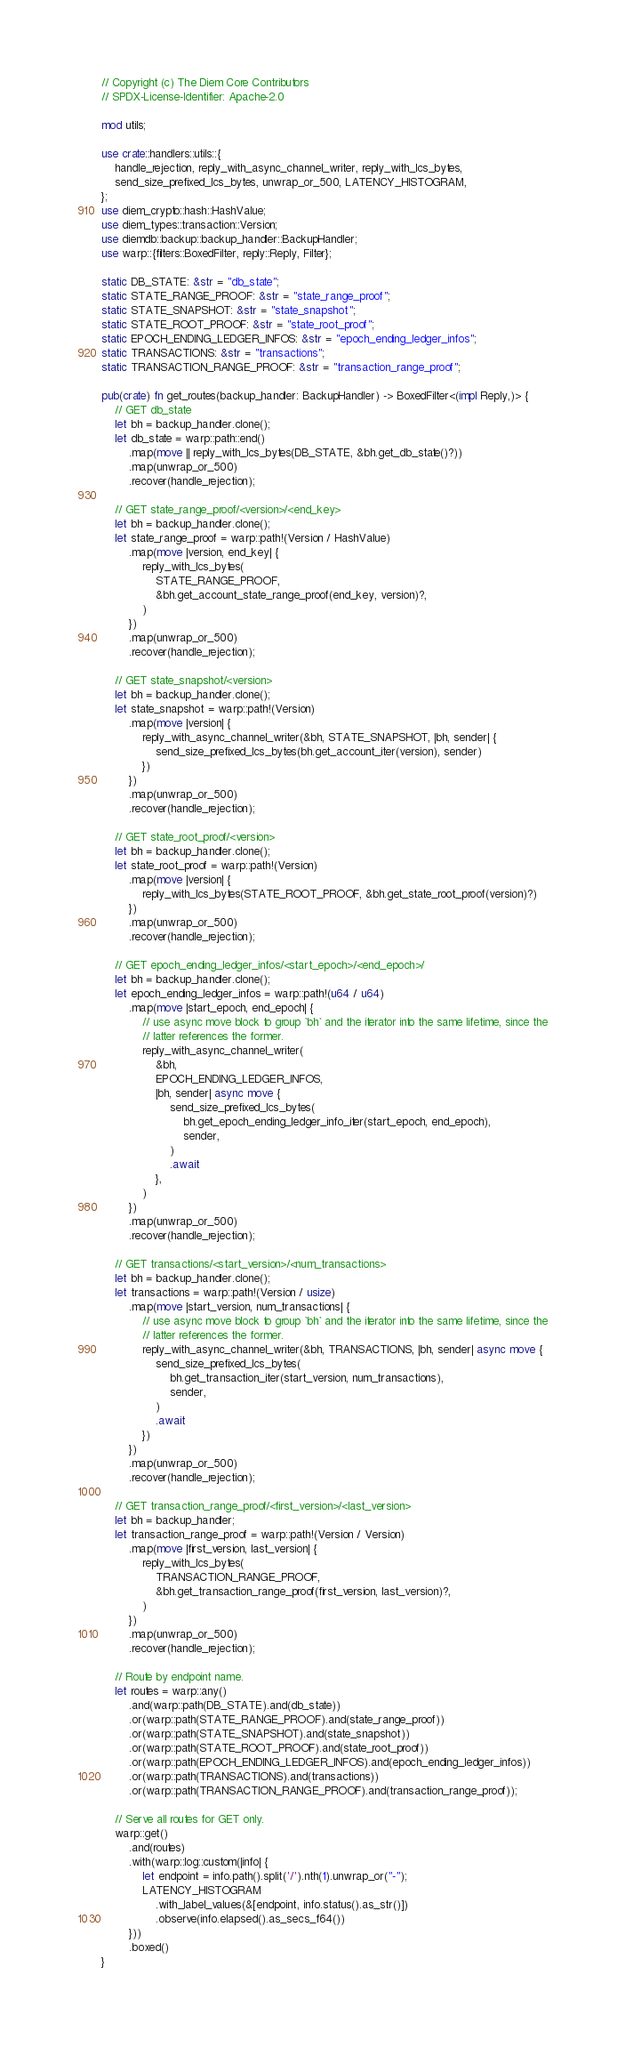<code> <loc_0><loc_0><loc_500><loc_500><_Rust_>// Copyright (c) The Diem Core Contributors
// SPDX-License-Identifier: Apache-2.0

mod utils;

use crate::handlers::utils::{
    handle_rejection, reply_with_async_channel_writer, reply_with_lcs_bytes,
    send_size_prefixed_lcs_bytes, unwrap_or_500, LATENCY_HISTOGRAM,
};
use diem_crypto::hash::HashValue;
use diem_types::transaction::Version;
use diemdb::backup::backup_handler::BackupHandler;
use warp::{filters::BoxedFilter, reply::Reply, Filter};

static DB_STATE: &str = "db_state";
static STATE_RANGE_PROOF: &str = "state_range_proof";
static STATE_SNAPSHOT: &str = "state_snapshot";
static STATE_ROOT_PROOF: &str = "state_root_proof";
static EPOCH_ENDING_LEDGER_INFOS: &str = "epoch_ending_ledger_infos";
static TRANSACTIONS: &str = "transactions";
static TRANSACTION_RANGE_PROOF: &str = "transaction_range_proof";

pub(crate) fn get_routes(backup_handler: BackupHandler) -> BoxedFilter<(impl Reply,)> {
    // GET db_state
    let bh = backup_handler.clone();
    let db_state = warp::path::end()
        .map(move || reply_with_lcs_bytes(DB_STATE, &bh.get_db_state()?))
        .map(unwrap_or_500)
        .recover(handle_rejection);

    // GET state_range_proof/<version>/<end_key>
    let bh = backup_handler.clone();
    let state_range_proof = warp::path!(Version / HashValue)
        .map(move |version, end_key| {
            reply_with_lcs_bytes(
                STATE_RANGE_PROOF,
                &bh.get_account_state_range_proof(end_key, version)?,
            )
        })
        .map(unwrap_or_500)
        .recover(handle_rejection);

    // GET state_snapshot/<version>
    let bh = backup_handler.clone();
    let state_snapshot = warp::path!(Version)
        .map(move |version| {
            reply_with_async_channel_writer(&bh, STATE_SNAPSHOT, |bh, sender| {
                send_size_prefixed_lcs_bytes(bh.get_account_iter(version), sender)
            })
        })
        .map(unwrap_or_500)
        .recover(handle_rejection);

    // GET state_root_proof/<version>
    let bh = backup_handler.clone();
    let state_root_proof = warp::path!(Version)
        .map(move |version| {
            reply_with_lcs_bytes(STATE_ROOT_PROOF, &bh.get_state_root_proof(version)?)
        })
        .map(unwrap_or_500)
        .recover(handle_rejection);

    // GET epoch_ending_ledger_infos/<start_epoch>/<end_epoch>/
    let bh = backup_handler.clone();
    let epoch_ending_ledger_infos = warp::path!(u64 / u64)
        .map(move |start_epoch, end_epoch| {
            // use async move block to group `bh` and the iterator into the same lifetime, since the
            // latter references the former.
            reply_with_async_channel_writer(
                &bh,
                EPOCH_ENDING_LEDGER_INFOS,
                |bh, sender| async move {
                    send_size_prefixed_lcs_bytes(
                        bh.get_epoch_ending_ledger_info_iter(start_epoch, end_epoch),
                        sender,
                    )
                    .await
                },
            )
        })
        .map(unwrap_or_500)
        .recover(handle_rejection);

    // GET transactions/<start_version>/<num_transactions>
    let bh = backup_handler.clone();
    let transactions = warp::path!(Version / usize)
        .map(move |start_version, num_transactions| {
            // use async move block to group `bh` and the iterator into the same lifetime, since the
            // latter references the former.
            reply_with_async_channel_writer(&bh, TRANSACTIONS, |bh, sender| async move {
                send_size_prefixed_lcs_bytes(
                    bh.get_transaction_iter(start_version, num_transactions),
                    sender,
                )
                .await
            })
        })
        .map(unwrap_or_500)
        .recover(handle_rejection);

    // GET transaction_range_proof/<first_version>/<last_version>
    let bh = backup_handler;
    let transaction_range_proof = warp::path!(Version / Version)
        .map(move |first_version, last_version| {
            reply_with_lcs_bytes(
                TRANSACTION_RANGE_PROOF,
                &bh.get_transaction_range_proof(first_version, last_version)?,
            )
        })
        .map(unwrap_or_500)
        .recover(handle_rejection);

    // Route by endpoint name.
    let routes = warp::any()
        .and(warp::path(DB_STATE).and(db_state))
        .or(warp::path(STATE_RANGE_PROOF).and(state_range_proof))
        .or(warp::path(STATE_SNAPSHOT).and(state_snapshot))
        .or(warp::path(STATE_ROOT_PROOF).and(state_root_proof))
        .or(warp::path(EPOCH_ENDING_LEDGER_INFOS).and(epoch_ending_ledger_infos))
        .or(warp::path(TRANSACTIONS).and(transactions))
        .or(warp::path(TRANSACTION_RANGE_PROOF).and(transaction_range_proof));

    // Serve all routes for GET only.
    warp::get()
        .and(routes)
        .with(warp::log::custom(|info| {
            let endpoint = info.path().split('/').nth(1).unwrap_or("-");
            LATENCY_HISTOGRAM
                .with_label_values(&[endpoint, info.status().as_str()])
                .observe(info.elapsed().as_secs_f64())
        }))
        .boxed()
}
</code> 